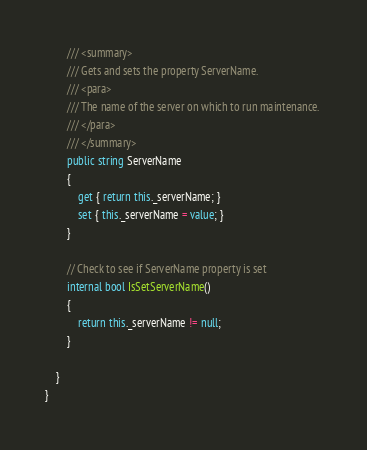<code> <loc_0><loc_0><loc_500><loc_500><_C#_>
        /// <summary>
        /// Gets and sets the property ServerName. 
        /// <para>
        /// The name of the server on which to run maintenance. 
        /// </para>
        /// </summary>
        public string ServerName
        {
            get { return this._serverName; }
            set { this._serverName = value; }
        }

        // Check to see if ServerName property is set
        internal bool IsSetServerName()
        {
            return this._serverName != null;
        }

    }
}</code> 